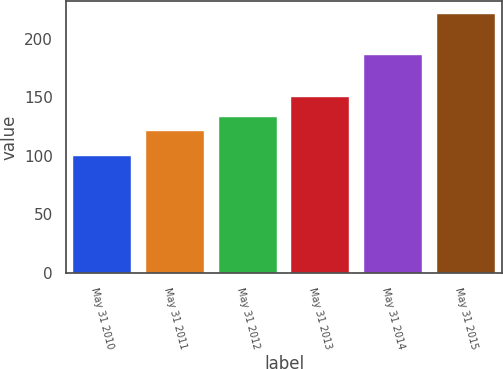Convert chart. <chart><loc_0><loc_0><loc_500><loc_500><bar_chart><fcel>May 31 2010<fcel>May 31 2011<fcel>May 31 2012<fcel>May 31 2013<fcel>May 31 2014<fcel>May 31 2015<nl><fcel>100<fcel>121.13<fcel>133.21<fcel>150<fcel>185.84<fcel>220.8<nl></chart> 